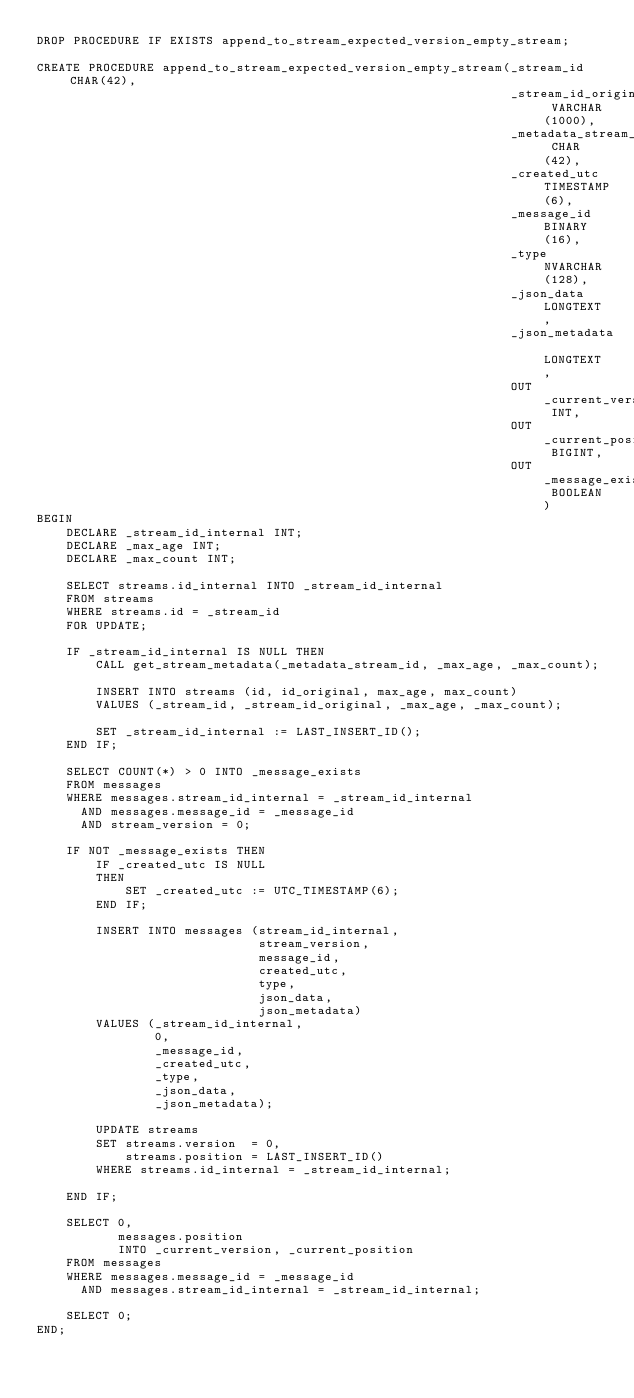Convert code to text. <code><loc_0><loc_0><loc_500><loc_500><_SQL_>DROP PROCEDURE IF EXISTS append_to_stream_expected_version_empty_stream;

CREATE PROCEDURE append_to_stream_expected_version_empty_stream(_stream_id CHAR(42),
                                                                _stream_id_original VARCHAR(1000),
                                                                _metadata_stream_id CHAR(42),
                                                                _created_utc TIMESTAMP(6),
                                                                _message_id BINARY(16),
                                                                _type NVARCHAR(128),
                                                                _json_data LONGTEXT,
                                                                _json_metadata LONGTEXT,
                                                                OUT _current_version INT,
                                                                OUT _current_position BIGINT,
                                                                OUT _message_exists BOOLEAN)
BEGIN
    DECLARE _stream_id_internal INT;
    DECLARE _max_age INT;
    DECLARE _max_count INT;

    SELECT streams.id_internal INTO _stream_id_internal
    FROM streams
    WHERE streams.id = _stream_id
    FOR UPDATE;

    IF _stream_id_internal IS NULL THEN
        CALL get_stream_metadata(_metadata_stream_id, _max_age, _max_count);

        INSERT INTO streams (id, id_original, max_age, max_count)
        VALUES (_stream_id, _stream_id_original, _max_age, _max_count);

        SET _stream_id_internal := LAST_INSERT_ID();
    END IF;

    SELECT COUNT(*) > 0 INTO _message_exists
    FROM messages
    WHERE messages.stream_id_internal = _stream_id_internal
      AND messages.message_id = _message_id
      AND stream_version = 0;

    IF NOT _message_exists THEN
        IF _created_utc IS NULL
        THEN
            SET _created_utc := UTC_TIMESTAMP(6);
        END IF;

        INSERT INTO messages (stream_id_internal,
                              stream_version,
                              message_id,
                              created_utc,
                              type,
                              json_data,
                              json_metadata)
        VALUES (_stream_id_internal,
                0,
                _message_id,
                _created_utc,
                _type,
                _json_data,
                _json_metadata);

        UPDATE streams
        SET streams.version  = 0,
            streams.position = LAST_INSERT_ID()
        WHERE streams.id_internal = _stream_id_internal;

    END IF;

    SELECT 0,
           messages.position
           INTO _current_version, _current_position
    FROM messages
    WHERE messages.message_id = _message_id
      AND messages.stream_id_internal = _stream_id_internal;

    SELECT 0;
END;
</code> 